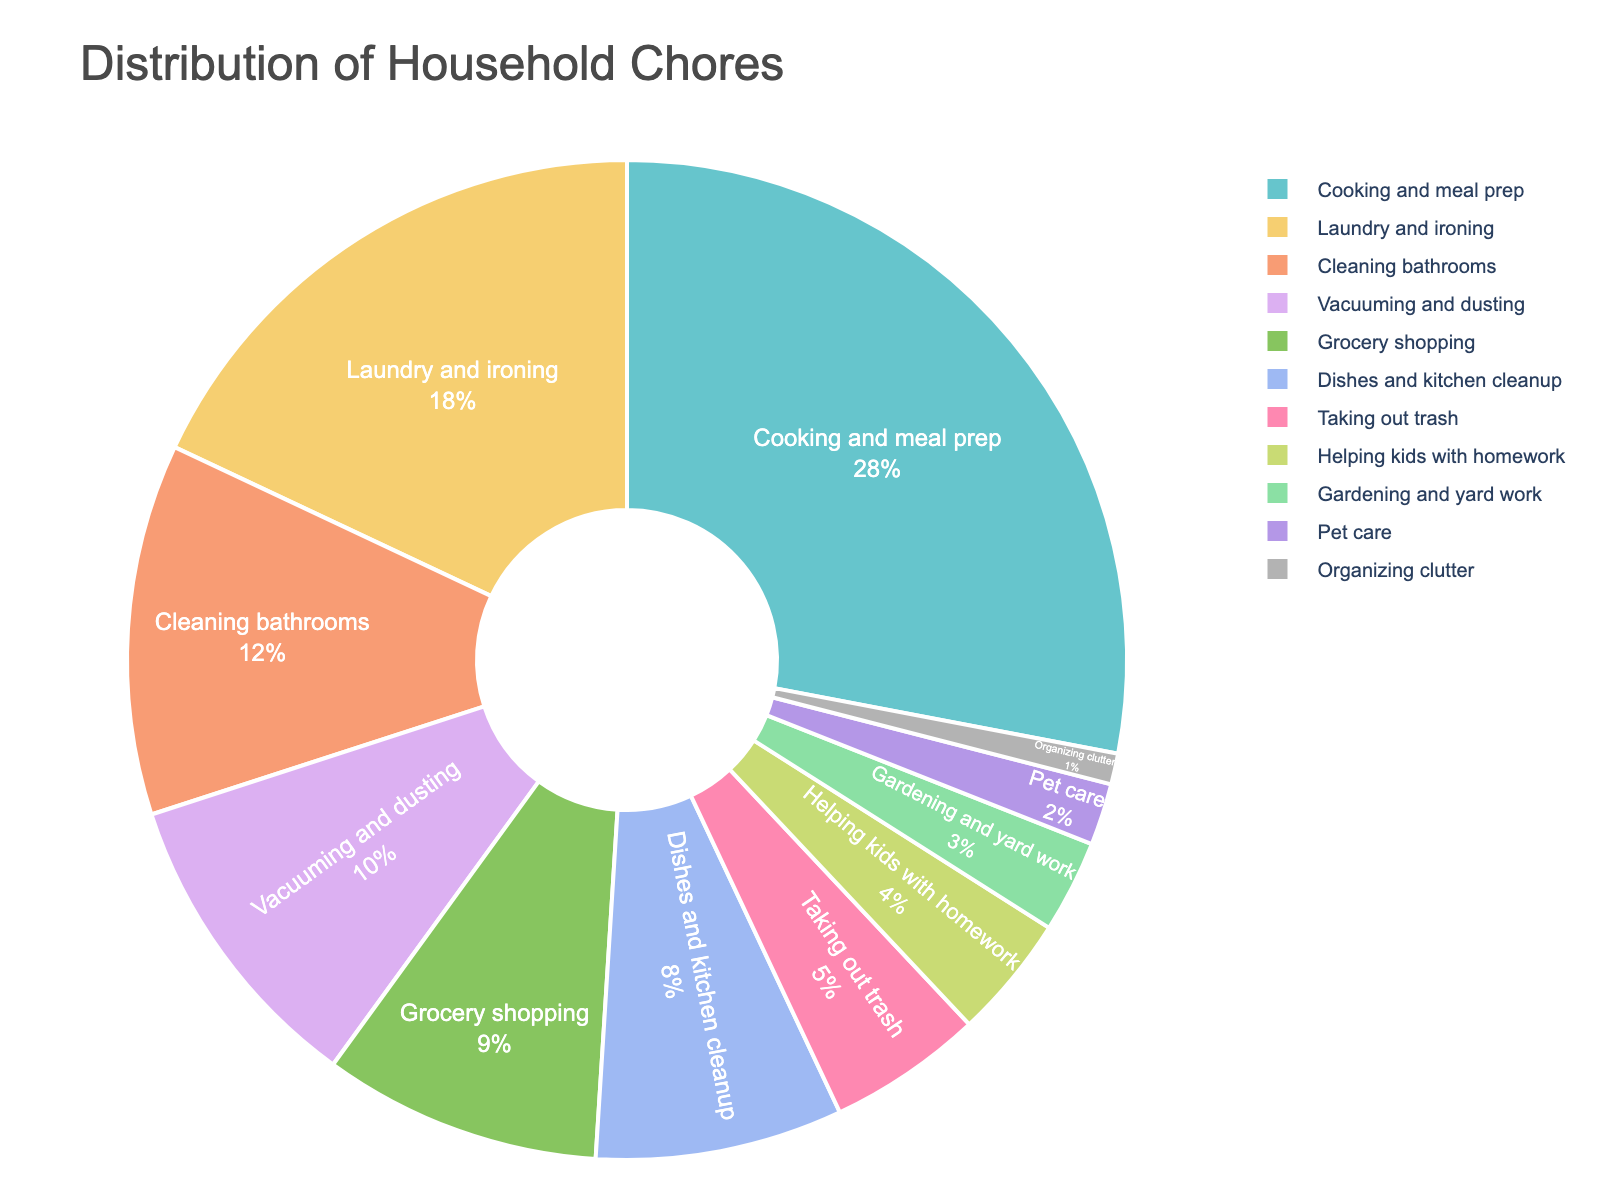What's the most common household chore in the pie chart? The most common chore will be the segment with the largest percentage in the chart. From the pie chart, "Cooking and meal prep" has the highest percentage at 28%.
Answer: Cooking and meal prep Which chore has the smallest percentage allocated? The smallest percentage will be the smallest segment in the chart. The pie chart shows that "Organizing clutter" has the smallest percentage at 1%.
Answer: Organizing clutter What are the combined percentages of "Laundry and ironing" and "Cleaning bathrooms"? For these two chores, add their percentages together. "Laundry and ironing" is 18% and "Cleaning bathrooms" is 12%, so 18% + 12% = 30%.
Answer: 30% Are there more chores allocated more than or equal to 10% or less than 10%? First, count the number of segments above or equal to 10% and those below 10%. More than or equal to 10%: "Cooking and meal prep" (28%), "Laundry and ironing" (18%), "Cleaning bathrooms" (12%), "Vacuuming and dusting" (10%). Fewer than 10%: The rest ("Grocery shopping", "Dishes and kitchen cleanup", etc.). Therefore, there are 4 chores >= 10% and 7 chores < 10%. So, more chores have less than 10%.
Answer: Less than 10% What percentage of chores is allocated to "Grocery shopping" and "Pet care" combined? Add the percentages of "Grocery shopping" and "Pet care". "Grocery shopping" is 9% and "Pet care" is 2%, so 9% + 2% = 11%.
Answer: 11% Which chores collectively make up more than half of the pie chart? Sum the percentages starting from the largest segment until the total exceeds 50%. "Cooking and meal prep" (28%) + "Laundry and ironing" (18%) = 46%. Adding "Cleaning bathrooms" (12%) gives us 46% + 12% = 58%, which is more than half the pie. Therefore, "Cooking and meal prep", "Laundry and ironing", and "Cleaning bathrooms" collectively make up more than 50%.
Answer: Cooking and meal prep, Laundry and ironing, Cleaning bathrooms Is the percentage of "Vacuuming and dusting" equal to or greater than that of "Grocery shopping"? Compare the two percentages given in the pie chart. "Vacuuming and dusting" is 10% and "Grocery shopping" is 9%. 10% is greater than 9%.
Answer: Greater than What is the difference in percentage between "Taking out trash" and "Helping kids with homework"? Subtract the percentage of "Helping kids with homework" from that of "Taking out trash". "Taking out trash" is 5% and "Helping kids with homework" is 4%, so 5% - 4% = 1%.
Answer: 1% How many chores have a percentage distribution between 5% and 15% inclusive? Count the segments that fall within the 5% to 15% range inclusive. "Cleaning bathrooms" (12%), "Vacuuming and dusting" (10%), "Grocery shopping" (9%), "Dishes and kitchen cleanup" (8%), and "Taking out trash" (5%) all fall within this range. Therefore, there are 5 chores.
Answer: 5 What is the average percentage of "Gardening and yard work", "Pet care", and "Organizing clutter"? Calculate the average by adding their percentages and dividing by the number of chores. "Gardening and yard work" is 3%, "Pet care" is 2%, and "Organizing clutter" is 1%. So, (3% + 2% + 1%) / 3 = 6% / 3 = 2%.
Answer: 2% 